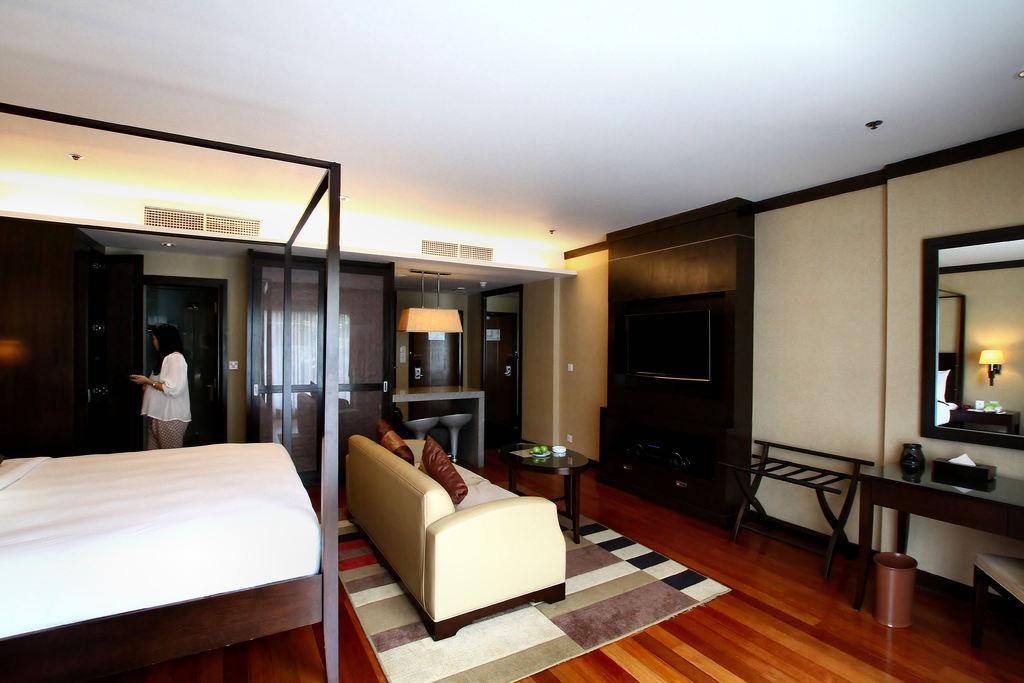In one or two sentences, can you explain what this image depicts? In this image i can see a woman is standing on the floor. I can also see there is a bed, a couch, a mirror and a table. 